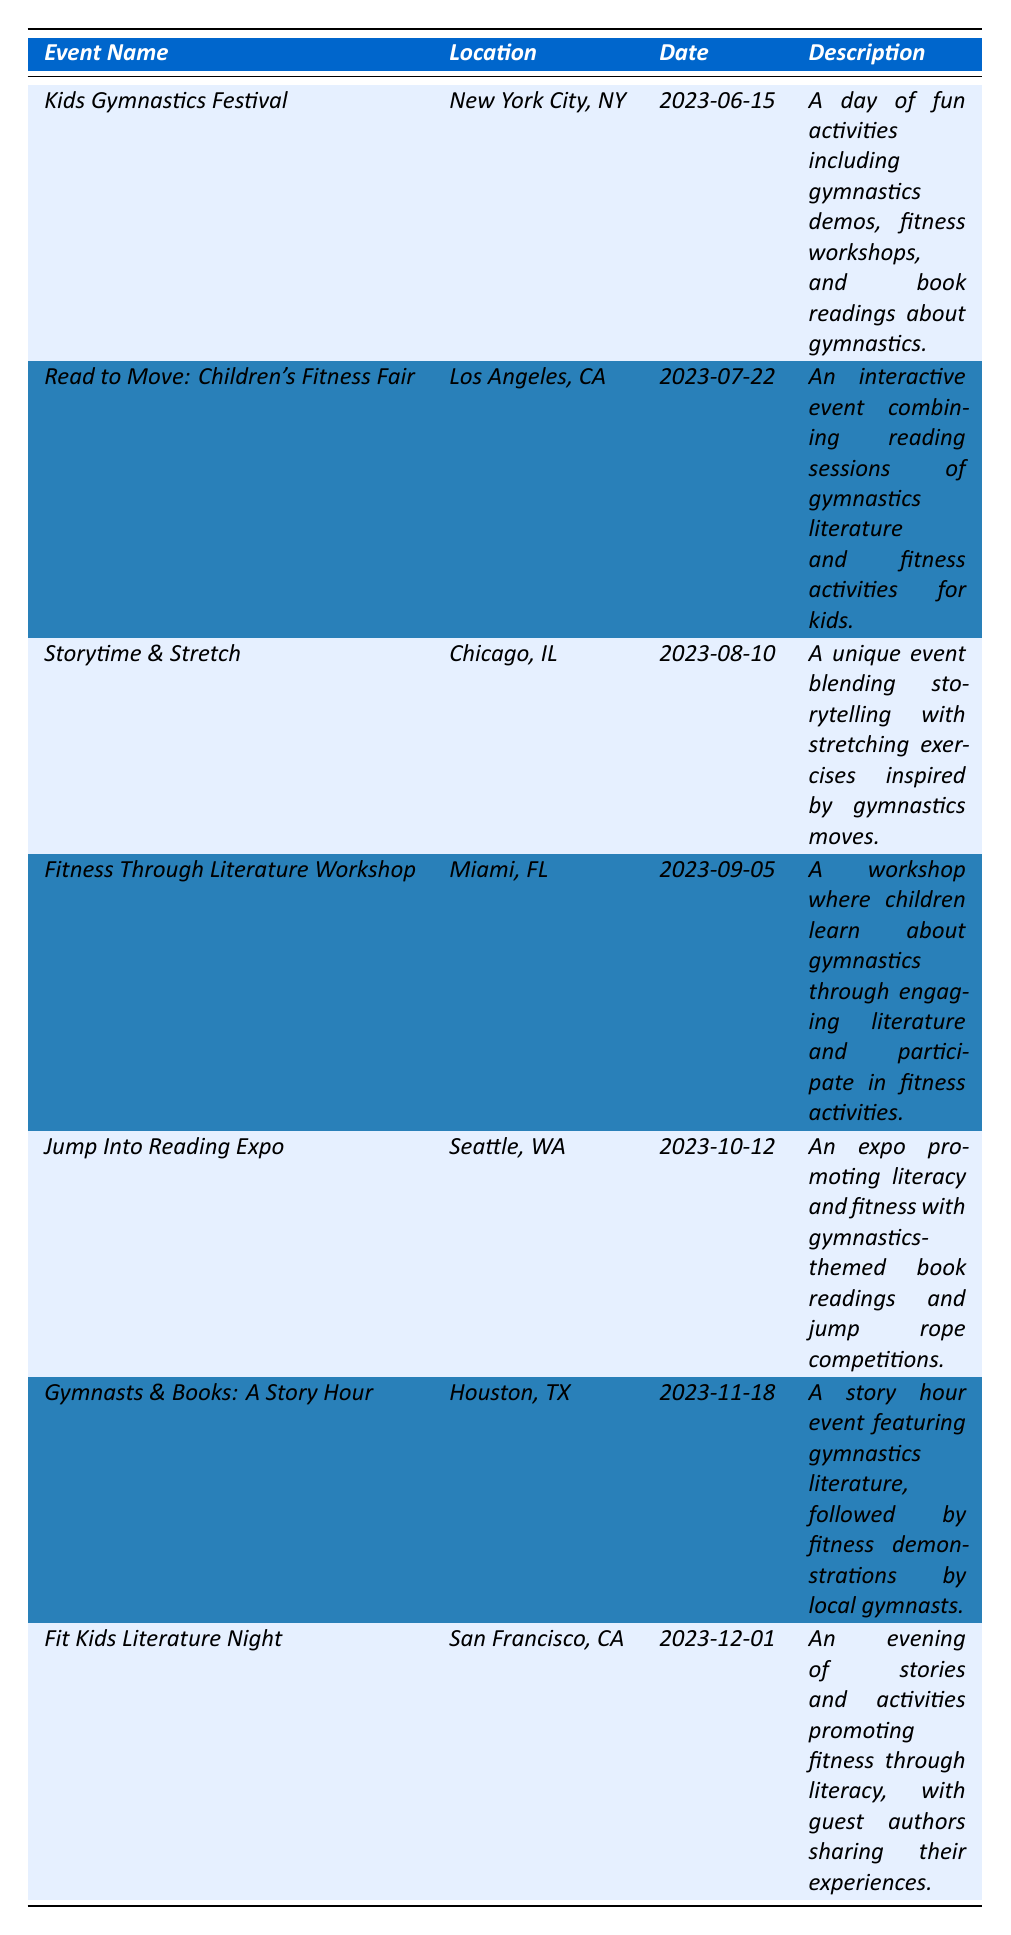What is the date of the Kids Gymnastics Festival? The Kids Gymnastics Festival is listed in the table with its date noted as June 15, 2023.
Answer: June 15, 2023 Which event takes place in Miami? The event that takes place in Miami is identified as the "Fitness Through Literature Workshop" in the table.
Answer: Fitness Through Literature Workshop How many events are scheduled for the month of October? The table lists two events scheduled for October: "Jump Into Reading Expo" on October 12 and "Gymnasts & Books: A Story Hour" on November 18, making a total of one event in October.
Answer: 1 What is the location of the event that targets preschool children? The event targeting preschool children is "Storytime & Stretch," which is located in Chicago, IL, as mentioned in the table.
Answer: Chicago, IL Is there an event aimed at families and educators? Yes, the "Read to Move: Children's Fitness Fair" is aimed at families and educators based on its audience description in the table.
Answer: Yes Which organization is hosting the "Jump Into Reading Expo"? The organization hosting the "Jump Into Reading Expo" is identified as the "Seattle Reads Initiative" in the table.
Answer: Seattle Reads Initiative What is the common theme of all listed events? Each event shares a common theme of promoting children's fitness and gymnastics literature through various interactive activities.
Answer: Fitness and gymnastics literature How many events specifically mention fitness activities? Upon reviewing the descriptions, all seven events, including phrases like “fitness workshops,” “fitness activities,” and “fitness demonstrations,” indicate a focus on fitness activities, totaling seven events.
Answer: 7 Which event occurs last in the year? The last event in the provided list is "Fit Kids Literature Night," scheduled for December 1, 2023, making it the final event of the year based on the dates provided.
Answer: December 1, 2023 What audience demographic is targeted by the "Gymnasts & Books: A Story Hour"? The demographic targeted by this event is children ages 5-10, as stated in the table under audience descriptions.
Answer: Children ages 5-10 Which city hosts the event that combines storytelling with stretching exercises? The city hosting the "Storytime & Stretch" event, which combines storytelling with stretching exercises, is Chicago, IL, based on the location listed in the table.
Answer: Chicago, IL What type of activities can participants expect at the "Kids Gymnastics Festival"? Participants can expect a day of fun activities including gymnastics demos, fitness workshops, and book readings relating to gymnastics, as detailed in the event's description.
Answer: Gymnastics demos, fitness workshops, and book readings Which event in the table features guest authors? The event that features guest authors is "Fit Kids Literature Night," where guest authors share their experiences as noted in the description.
Answer: Fit Kids Literature Night 